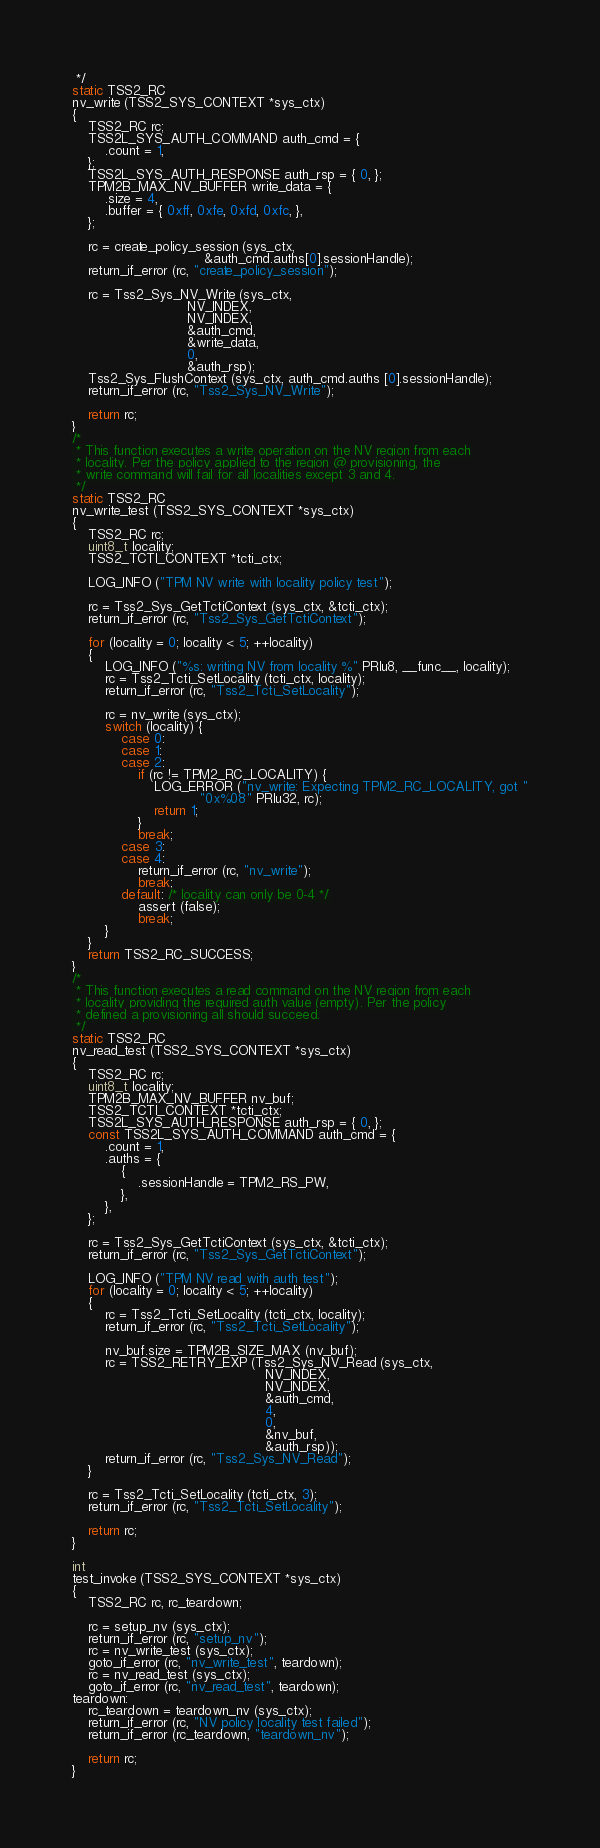Convert code to text. <code><loc_0><loc_0><loc_500><loc_500><_C_> */
static TSS2_RC
nv_write (TSS2_SYS_CONTEXT *sys_ctx)
{
    TSS2_RC rc;
    TSS2L_SYS_AUTH_COMMAND auth_cmd = {
        .count = 1,
    };
    TSS2L_SYS_AUTH_RESPONSE auth_rsp = { 0, };
    TPM2B_MAX_NV_BUFFER write_data = {
        .size = 4,
        .buffer = { 0xff, 0xfe, 0xfd, 0xfc, },
    };

    rc = create_policy_session (sys_ctx,
                                &auth_cmd.auths[0].sessionHandle);
    return_if_error (rc, "create_policy_session");

    rc = Tss2_Sys_NV_Write (sys_ctx,
                            NV_INDEX,
                            NV_INDEX,
                            &auth_cmd,
                            &write_data,
                            0,
                            &auth_rsp);
    Tss2_Sys_FlushContext (sys_ctx, auth_cmd.auths [0].sessionHandle);
    return_if_error (rc, "Tss2_Sys_NV_Write");

    return rc;
}
/*
 * This function executes a write operation on the NV region from each
 * locality. Per the policy applied to the region @ provisioning, the
 * write command will fail for all localities except 3 and 4.
 */
static TSS2_RC
nv_write_test (TSS2_SYS_CONTEXT *sys_ctx)
{
    TSS2_RC rc;
    uint8_t locality;
    TSS2_TCTI_CONTEXT *tcti_ctx;

    LOG_INFO ("TPM NV write with locality policy test");

    rc = Tss2_Sys_GetTctiContext (sys_ctx, &tcti_ctx);
    return_if_error (rc, "Tss2_Sys_GetTctiContext");

    for (locality = 0; locality < 5; ++locality)
    {
        LOG_INFO ("%s: writing NV from locality %" PRIu8, __func__, locality);
        rc = Tss2_Tcti_SetLocality (tcti_ctx, locality);
        return_if_error (rc, "Tss2_Tcti_SetLocality");

        rc = nv_write (sys_ctx);
        switch (locality) {
            case 0:
            case 1:
            case 2:
                if (rc != TPM2_RC_LOCALITY) {
                    LOG_ERROR ("nv_write: Expecting TPM2_RC_LOCALITY, got "
                               "0x%08" PRIu32, rc);
                    return 1;
                }
                break;
            case 3:
            case 4:
                return_if_error (rc, "nv_write");
                break;
            default: /* locality can only be 0-4 */
                assert (false);
                break;
        }
    }
    return TSS2_RC_SUCCESS;
}
/*
 * This function executes a read command on the NV region from each
 * locality providing the required auth value (empty). Per the policy
 * defined a provisioning all should succeed.
 */
static TSS2_RC
nv_read_test (TSS2_SYS_CONTEXT *sys_ctx)
{
    TSS2_RC rc;
    uint8_t locality;
    TPM2B_MAX_NV_BUFFER nv_buf;
    TSS2_TCTI_CONTEXT *tcti_ctx;
    TSS2L_SYS_AUTH_RESPONSE auth_rsp = { 0, };
    const TSS2L_SYS_AUTH_COMMAND auth_cmd = {
        .count = 1,
        .auths = {
            {
                .sessionHandle = TPM2_RS_PW,
            },
        },
    };

    rc = Tss2_Sys_GetTctiContext (sys_ctx, &tcti_ctx);
    return_if_error (rc, "Tss2_Sys_GetTctiContext");

    LOG_INFO ("TPM NV read with auth test");
    for (locality = 0; locality < 5; ++locality)
    {
        rc = Tss2_Tcti_SetLocality (tcti_ctx, locality);
        return_if_error (rc, "Tss2_Tcti_SetLocality");

        nv_buf.size = TPM2B_SIZE_MAX (nv_buf);
        rc = TSS2_RETRY_EXP (Tss2_Sys_NV_Read (sys_ctx,
                                               NV_INDEX,
                                               NV_INDEX,
                                               &auth_cmd,
                                               4,
                                               0,
                                               &nv_buf,
                                               &auth_rsp));
        return_if_error (rc, "Tss2_Sys_NV_Read");
    }

    rc = Tss2_Tcti_SetLocality (tcti_ctx, 3);
    return_if_error (rc, "Tss2_Tcti_SetLocality");

    return rc;
}

int
test_invoke (TSS2_SYS_CONTEXT *sys_ctx)
{
    TSS2_RC rc, rc_teardown;

    rc = setup_nv (sys_ctx);
    return_if_error (rc, "setup_nv");
    rc = nv_write_test (sys_ctx);
    goto_if_error (rc, "nv_write_test", teardown);
    rc = nv_read_test (sys_ctx);
    goto_if_error (rc, "nv_read_test", teardown);
teardown:
    rc_teardown = teardown_nv (sys_ctx);
    return_if_error (rc, "NV policy locality test failed");
    return_if_error (rc_teardown, "teardown_nv");

    return rc;
}
</code> 